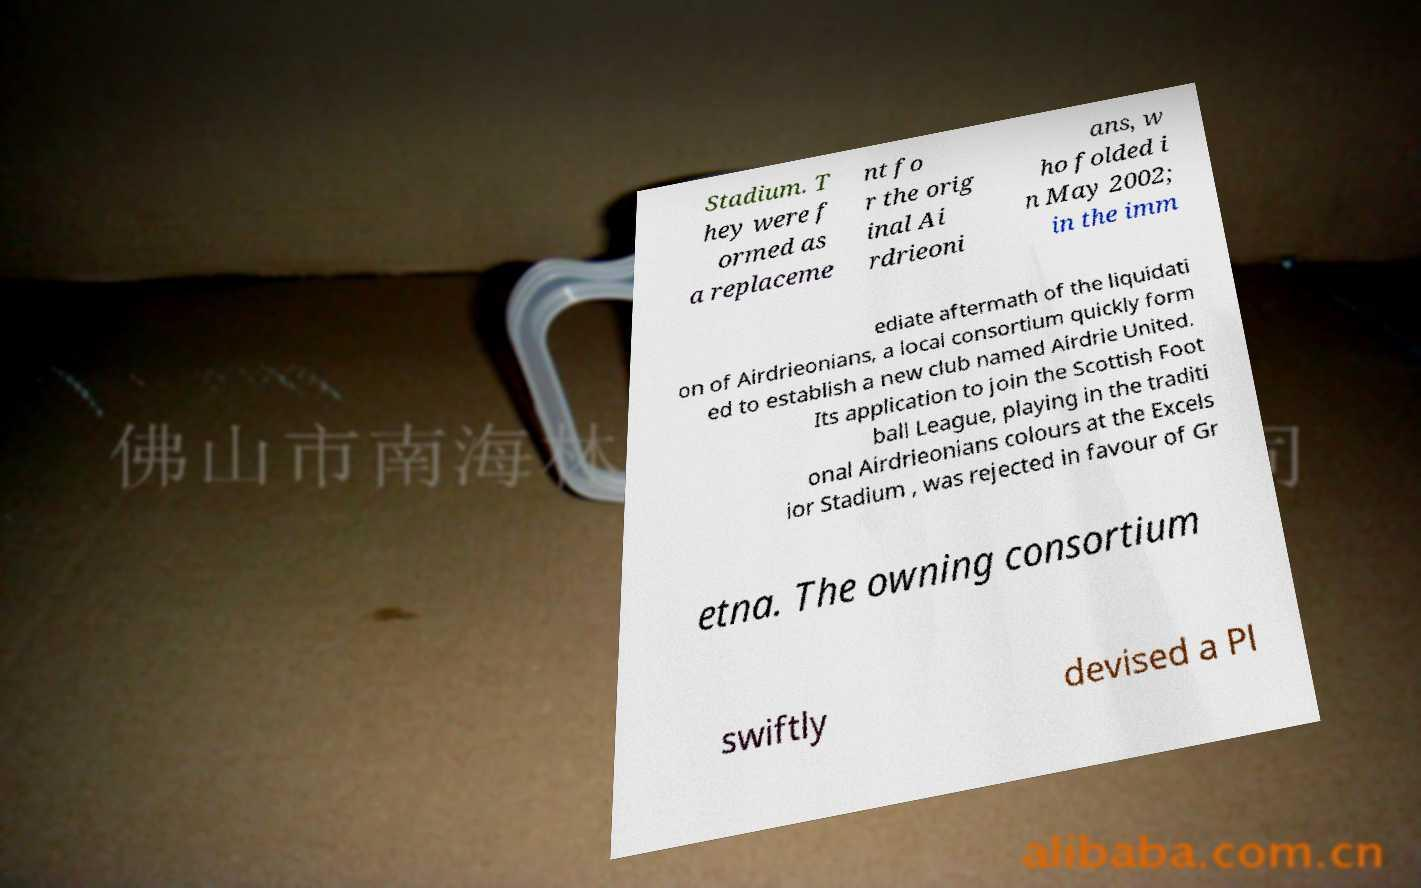What messages or text are displayed in this image? I need them in a readable, typed format. Stadium. T hey were f ormed as a replaceme nt fo r the orig inal Ai rdrieoni ans, w ho folded i n May 2002; in the imm ediate aftermath of the liquidati on of Airdrieonians, a local consortium quickly form ed to establish a new club named Airdrie United. Its application to join the Scottish Foot ball League, playing in the traditi onal Airdrieonians colours at the Excels ior Stadium , was rejected in favour of Gr etna. The owning consortium swiftly devised a Pl 